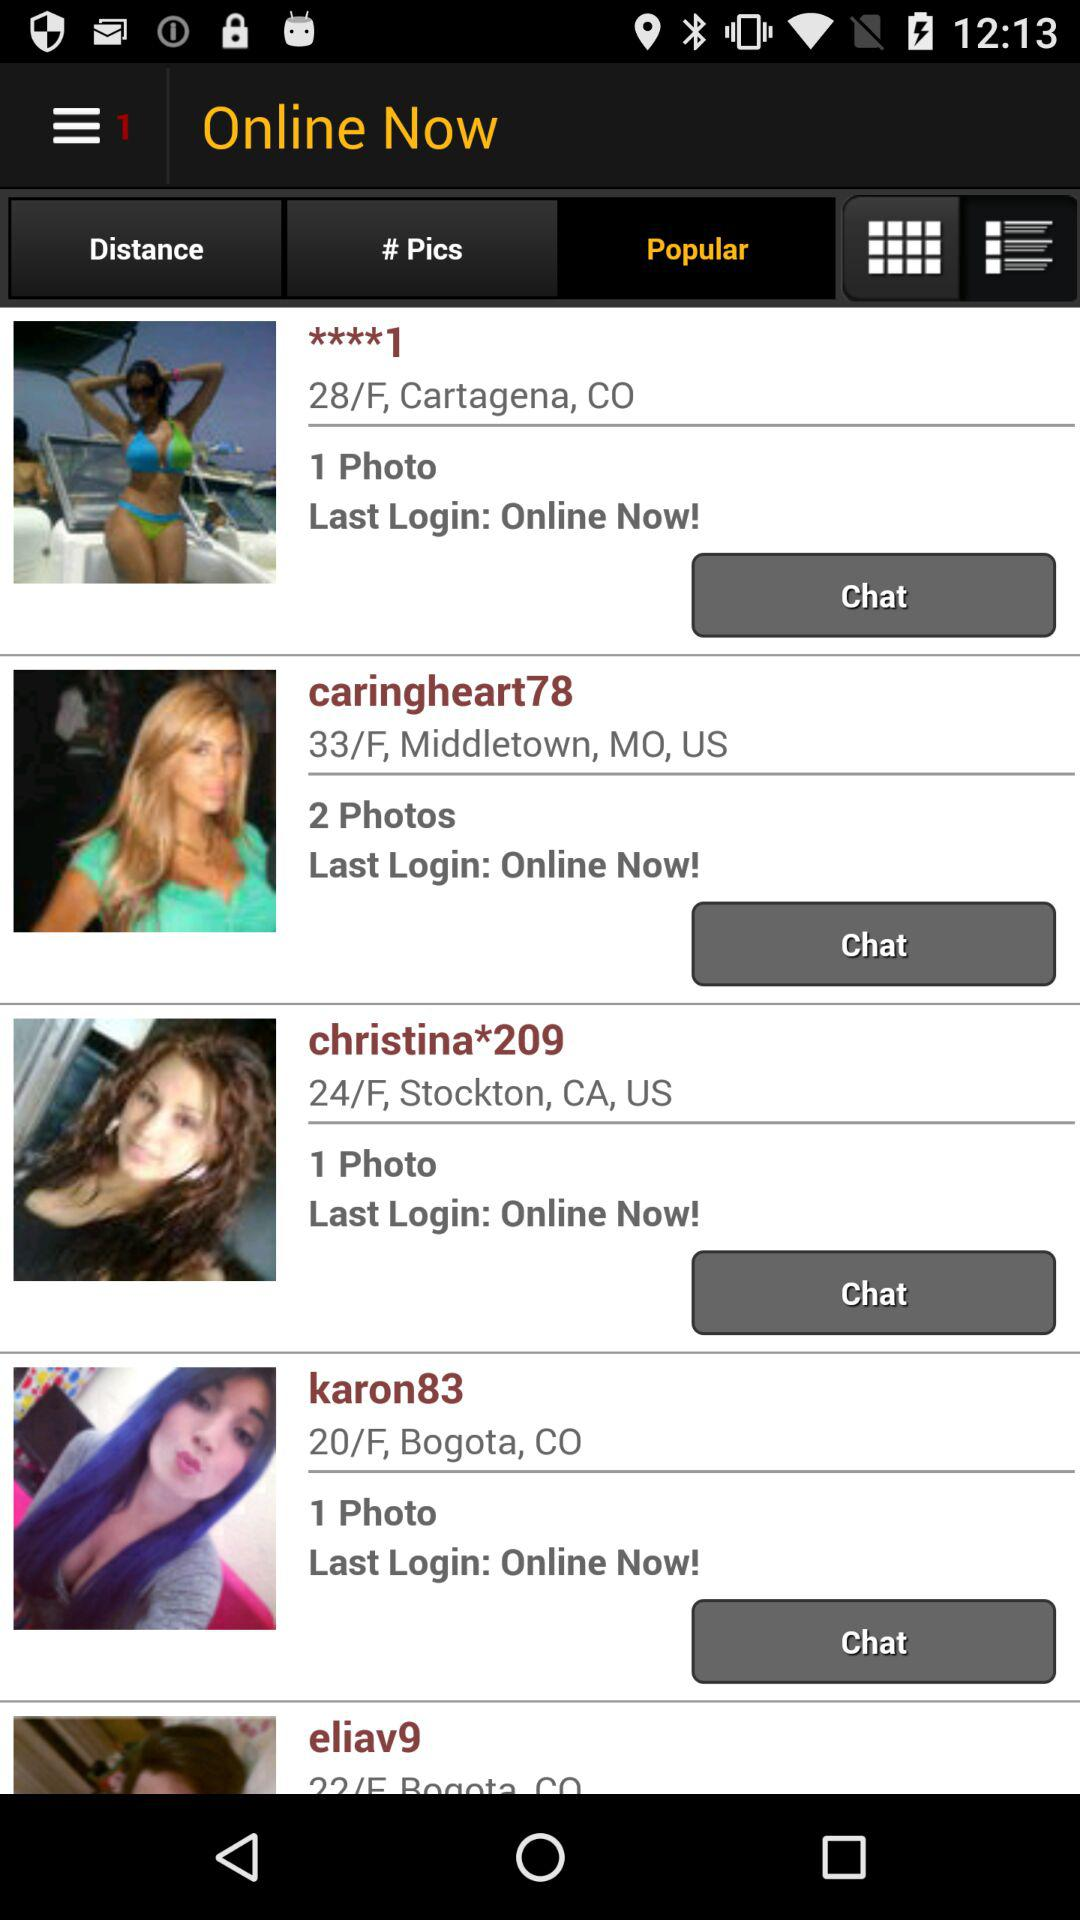What's the login status of "Christina*209"? The login status of "Christina*209" is "Online Now!". 